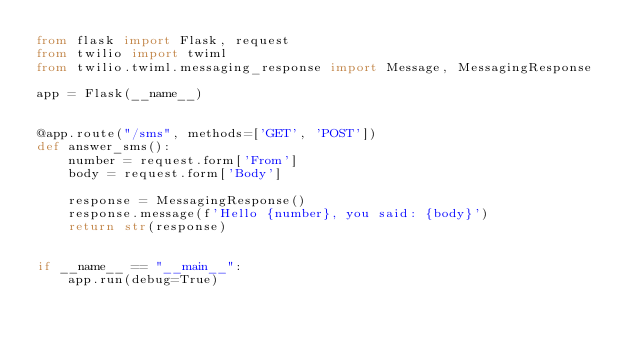Convert code to text. <code><loc_0><loc_0><loc_500><loc_500><_Python_>from flask import Flask, request
from twilio import twiml
from twilio.twiml.messaging_response import Message, MessagingResponse

app = Flask(__name__)


@app.route("/sms", methods=['GET', 'POST'])
def answer_sms():
    number = request.form['From']
    body = request.form['Body']

    response = MessagingResponse()
    response.message(f'Hello {number}, you said: {body}')
    return str(response)


if __name__ == "__main__":
    app.run(debug=True)
</code> 